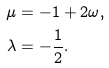<formula> <loc_0><loc_0><loc_500><loc_500>\mu & = - 1 + 2 \omega , \\ \lambda & = - \frac { 1 } { 2 } .</formula> 